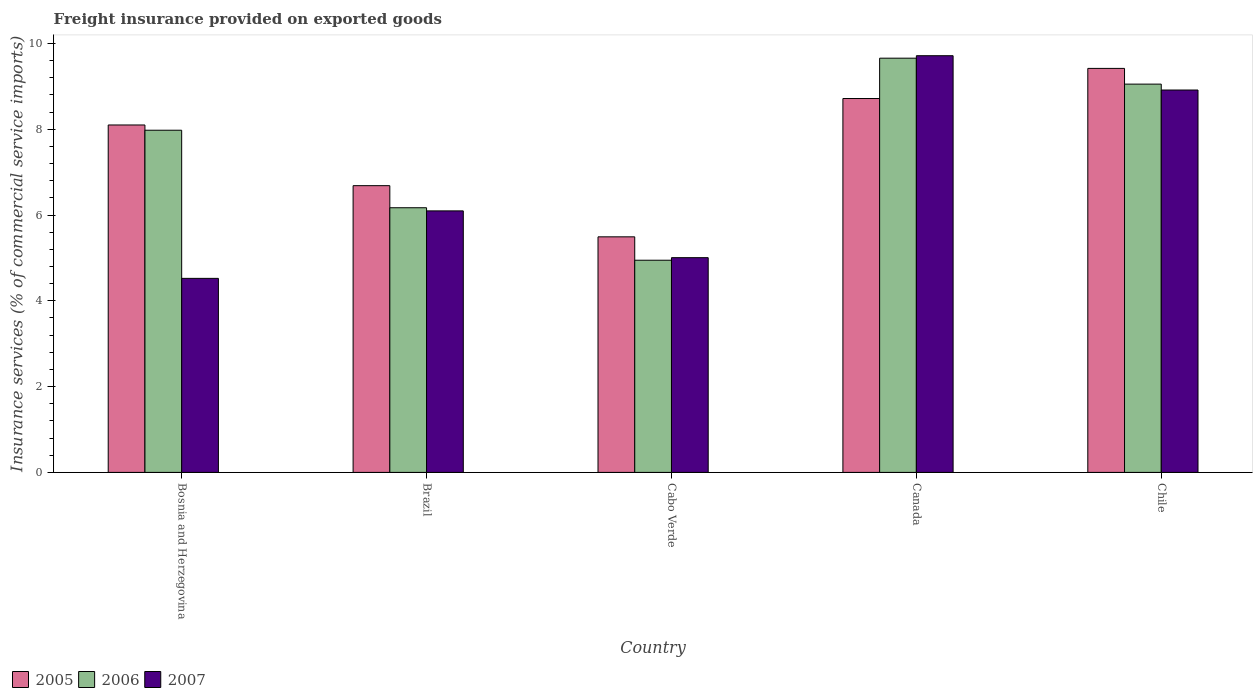How many different coloured bars are there?
Make the answer very short. 3. Are the number of bars per tick equal to the number of legend labels?
Your answer should be very brief. Yes. Are the number of bars on each tick of the X-axis equal?
Keep it short and to the point. Yes. How many bars are there on the 3rd tick from the right?
Your answer should be compact. 3. In how many cases, is the number of bars for a given country not equal to the number of legend labels?
Ensure brevity in your answer.  0. What is the freight insurance provided on exported goods in 2006 in Cabo Verde?
Your answer should be very brief. 4.95. Across all countries, what is the maximum freight insurance provided on exported goods in 2007?
Provide a short and direct response. 9.71. Across all countries, what is the minimum freight insurance provided on exported goods in 2007?
Provide a succinct answer. 4.52. In which country was the freight insurance provided on exported goods in 2006 minimum?
Your answer should be compact. Cabo Verde. What is the total freight insurance provided on exported goods in 2007 in the graph?
Ensure brevity in your answer.  34.25. What is the difference between the freight insurance provided on exported goods in 2007 in Canada and that in Chile?
Provide a short and direct response. 0.8. What is the difference between the freight insurance provided on exported goods in 2006 in Cabo Verde and the freight insurance provided on exported goods in 2005 in Bosnia and Herzegovina?
Ensure brevity in your answer.  -3.15. What is the average freight insurance provided on exported goods in 2007 per country?
Give a very brief answer. 6.85. What is the difference between the freight insurance provided on exported goods of/in 2007 and freight insurance provided on exported goods of/in 2006 in Bosnia and Herzegovina?
Your answer should be compact. -3.45. In how many countries, is the freight insurance provided on exported goods in 2007 greater than 9.2 %?
Give a very brief answer. 1. What is the ratio of the freight insurance provided on exported goods in 2005 in Brazil to that in Canada?
Give a very brief answer. 0.77. Is the difference between the freight insurance provided on exported goods in 2007 in Canada and Chile greater than the difference between the freight insurance provided on exported goods in 2006 in Canada and Chile?
Make the answer very short. Yes. What is the difference between the highest and the second highest freight insurance provided on exported goods in 2006?
Make the answer very short. 0.6. What is the difference between the highest and the lowest freight insurance provided on exported goods in 2005?
Provide a succinct answer. 3.93. In how many countries, is the freight insurance provided on exported goods in 2006 greater than the average freight insurance provided on exported goods in 2006 taken over all countries?
Your response must be concise. 3. Is the sum of the freight insurance provided on exported goods in 2006 in Bosnia and Herzegovina and Brazil greater than the maximum freight insurance provided on exported goods in 2007 across all countries?
Make the answer very short. Yes. What does the 2nd bar from the left in Canada represents?
Your answer should be very brief. 2006. Is it the case that in every country, the sum of the freight insurance provided on exported goods in 2007 and freight insurance provided on exported goods in 2006 is greater than the freight insurance provided on exported goods in 2005?
Keep it short and to the point. Yes. What is the difference between two consecutive major ticks on the Y-axis?
Make the answer very short. 2. Where does the legend appear in the graph?
Offer a very short reply. Bottom left. How are the legend labels stacked?
Your response must be concise. Horizontal. What is the title of the graph?
Provide a short and direct response. Freight insurance provided on exported goods. Does "1979" appear as one of the legend labels in the graph?
Make the answer very short. No. What is the label or title of the X-axis?
Provide a succinct answer. Country. What is the label or title of the Y-axis?
Offer a very short reply. Insurance services (% of commercial service imports). What is the Insurance services (% of commercial service imports) in 2005 in Bosnia and Herzegovina?
Ensure brevity in your answer.  8.1. What is the Insurance services (% of commercial service imports) of 2006 in Bosnia and Herzegovina?
Your response must be concise. 7.98. What is the Insurance services (% of commercial service imports) of 2007 in Bosnia and Herzegovina?
Ensure brevity in your answer.  4.52. What is the Insurance services (% of commercial service imports) in 2005 in Brazil?
Your answer should be compact. 6.68. What is the Insurance services (% of commercial service imports) in 2006 in Brazil?
Your answer should be very brief. 6.17. What is the Insurance services (% of commercial service imports) in 2007 in Brazil?
Your response must be concise. 6.1. What is the Insurance services (% of commercial service imports) in 2005 in Cabo Verde?
Ensure brevity in your answer.  5.49. What is the Insurance services (% of commercial service imports) of 2006 in Cabo Verde?
Ensure brevity in your answer.  4.95. What is the Insurance services (% of commercial service imports) in 2007 in Cabo Verde?
Make the answer very short. 5.01. What is the Insurance services (% of commercial service imports) of 2005 in Canada?
Keep it short and to the point. 8.72. What is the Insurance services (% of commercial service imports) of 2006 in Canada?
Provide a succinct answer. 9.66. What is the Insurance services (% of commercial service imports) of 2007 in Canada?
Offer a very short reply. 9.71. What is the Insurance services (% of commercial service imports) in 2005 in Chile?
Offer a terse response. 9.42. What is the Insurance services (% of commercial service imports) of 2006 in Chile?
Give a very brief answer. 9.05. What is the Insurance services (% of commercial service imports) in 2007 in Chile?
Provide a short and direct response. 8.91. Across all countries, what is the maximum Insurance services (% of commercial service imports) of 2005?
Give a very brief answer. 9.42. Across all countries, what is the maximum Insurance services (% of commercial service imports) in 2006?
Your answer should be very brief. 9.66. Across all countries, what is the maximum Insurance services (% of commercial service imports) in 2007?
Keep it short and to the point. 9.71. Across all countries, what is the minimum Insurance services (% of commercial service imports) in 2005?
Make the answer very short. 5.49. Across all countries, what is the minimum Insurance services (% of commercial service imports) of 2006?
Ensure brevity in your answer.  4.95. Across all countries, what is the minimum Insurance services (% of commercial service imports) in 2007?
Offer a very short reply. 4.52. What is the total Insurance services (% of commercial service imports) in 2005 in the graph?
Keep it short and to the point. 38.41. What is the total Insurance services (% of commercial service imports) of 2006 in the graph?
Keep it short and to the point. 37.8. What is the total Insurance services (% of commercial service imports) of 2007 in the graph?
Your answer should be compact. 34.25. What is the difference between the Insurance services (% of commercial service imports) of 2005 in Bosnia and Herzegovina and that in Brazil?
Your response must be concise. 1.41. What is the difference between the Insurance services (% of commercial service imports) in 2006 in Bosnia and Herzegovina and that in Brazil?
Ensure brevity in your answer.  1.81. What is the difference between the Insurance services (% of commercial service imports) in 2007 in Bosnia and Herzegovina and that in Brazil?
Your response must be concise. -1.57. What is the difference between the Insurance services (% of commercial service imports) in 2005 in Bosnia and Herzegovina and that in Cabo Verde?
Give a very brief answer. 2.61. What is the difference between the Insurance services (% of commercial service imports) of 2006 in Bosnia and Herzegovina and that in Cabo Verde?
Keep it short and to the point. 3.03. What is the difference between the Insurance services (% of commercial service imports) of 2007 in Bosnia and Herzegovina and that in Cabo Verde?
Your answer should be compact. -0.48. What is the difference between the Insurance services (% of commercial service imports) of 2005 in Bosnia and Herzegovina and that in Canada?
Ensure brevity in your answer.  -0.62. What is the difference between the Insurance services (% of commercial service imports) of 2006 in Bosnia and Herzegovina and that in Canada?
Your answer should be very brief. -1.68. What is the difference between the Insurance services (% of commercial service imports) in 2007 in Bosnia and Herzegovina and that in Canada?
Provide a short and direct response. -5.19. What is the difference between the Insurance services (% of commercial service imports) in 2005 in Bosnia and Herzegovina and that in Chile?
Provide a short and direct response. -1.32. What is the difference between the Insurance services (% of commercial service imports) of 2006 in Bosnia and Herzegovina and that in Chile?
Keep it short and to the point. -1.07. What is the difference between the Insurance services (% of commercial service imports) in 2007 in Bosnia and Herzegovina and that in Chile?
Your response must be concise. -4.39. What is the difference between the Insurance services (% of commercial service imports) of 2005 in Brazil and that in Cabo Verde?
Your answer should be very brief. 1.19. What is the difference between the Insurance services (% of commercial service imports) in 2006 in Brazil and that in Cabo Verde?
Your answer should be very brief. 1.22. What is the difference between the Insurance services (% of commercial service imports) in 2007 in Brazil and that in Cabo Verde?
Give a very brief answer. 1.09. What is the difference between the Insurance services (% of commercial service imports) of 2005 in Brazil and that in Canada?
Keep it short and to the point. -2.03. What is the difference between the Insurance services (% of commercial service imports) in 2006 in Brazil and that in Canada?
Provide a succinct answer. -3.49. What is the difference between the Insurance services (% of commercial service imports) of 2007 in Brazil and that in Canada?
Offer a terse response. -3.62. What is the difference between the Insurance services (% of commercial service imports) in 2005 in Brazil and that in Chile?
Ensure brevity in your answer.  -2.73. What is the difference between the Insurance services (% of commercial service imports) in 2006 in Brazil and that in Chile?
Offer a very short reply. -2.88. What is the difference between the Insurance services (% of commercial service imports) of 2007 in Brazil and that in Chile?
Provide a short and direct response. -2.82. What is the difference between the Insurance services (% of commercial service imports) of 2005 in Cabo Verde and that in Canada?
Your response must be concise. -3.22. What is the difference between the Insurance services (% of commercial service imports) in 2006 in Cabo Verde and that in Canada?
Provide a succinct answer. -4.71. What is the difference between the Insurance services (% of commercial service imports) in 2007 in Cabo Verde and that in Canada?
Provide a succinct answer. -4.71. What is the difference between the Insurance services (% of commercial service imports) of 2005 in Cabo Verde and that in Chile?
Ensure brevity in your answer.  -3.93. What is the difference between the Insurance services (% of commercial service imports) of 2006 in Cabo Verde and that in Chile?
Your answer should be very brief. -4.11. What is the difference between the Insurance services (% of commercial service imports) of 2007 in Cabo Verde and that in Chile?
Offer a very short reply. -3.91. What is the difference between the Insurance services (% of commercial service imports) of 2005 in Canada and that in Chile?
Provide a succinct answer. -0.7. What is the difference between the Insurance services (% of commercial service imports) of 2006 in Canada and that in Chile?
Give a very brief answer. 0.6. What is the difference between the Insurance services (% of commercial service imports) of 2007 in Canada and that in Chile?
Keep it short and to the point. 0.8. What is the difference between the Insurance services (% of commercial service imports) of 2005 in Bosnia and Herzegovina and the Insurance services (% of commercial service imports) of 2006 in Brazil?
Ensure brevity in your answer.  1.93. What is the difference between the Insurance services (% of commercial service imports) of 2005 in Bosnia and Herzegovina and the Insurance services (% of commercial service imports) of 2007 in Brazil?
Keep it short and to the point. 2. What is the difference between the Insurance services (% of commercial service imports) of 2006 in Bosnia and Herzegovina and the Insurance services (% of commercial service imports) of 2007 in Brazil?
Your answer should be very brief. 1.88. What is the difference between the Insurance services (% of commercial service imports) in 2005 in Bosnia and Herzegovina and the Insurance services (% of commercial service imports) in 2006 in Cabo Verde?
Offer a very short reply. 3.15. What is the difference between the Insurance services (% of commercial service imports) in 2005 in Bosnia and Herzegovina and the Insurance services (% of commercial service imports) in 2007 in Cabo Verde?
Your answer should be very brief. 3.09. What is the difference between the Insurance services (% of commercial service imports) of 2006 in Bosnia and Herzegovina and the Insurance services (% of commercial service imports) of 2007 in Cabo Verde?
Your response must be concise. 2.97. What is the difference between the Insurance services (% of commercial service imports) in 2005 in Bosnia and Herzegovina and the Insurance services (% of commercial service imports) in 2006 in Canada?
Your answer should be very brief. -1.56. What is the difference between the Insurance services (% of commercial service imports) of 2005 in Bosnia and Herzegovina and the Insurance services (% of commercial service imports) of 2007 in Canada?
Provide a succinct answer. -1.61. What is the difference between the Insurance services (% of commercial service imports) in 2006 in Bosnia and Herzegovina and the Insurance services (% of commercial service imports) in 2007 in Canada?
Provide a succinct answer. -1.74. What is the difference between the Insurance services (% of commercial service imports) in 2005 in Bosnia and Herzegovina and the Insurance services (% of commercial service imports) in 2006 in Chile?
Your response must be concise. -0.95. What is the difference between the Insurance services (% of commercial service imports) in 2005 in Bosnia and Herzegovina and the Insurance services (% of commercial service imports) in 2007 in Chile?
Your answer should be very brief. -0.81. What is the difference between the Insurance services (% of commercial service imports) in 2006 in Bosnia and Herzegovina and the Insurance services (% of commercial service imports) in 2007 in Chile?
Offer a terse response. -0.94. What is the difference between the Insurance services (% of commercial service imports) of 2005 in Brazil and the Insurance services (% of commercial service imports) of 2006 in Cabo Verde?
Offer a terse response. 1.74. What is the difference between the Insurance services (% of commercial service imports) in 2005 in Brazil and the Insurance services (% of commercial service imports) in 2007 in Cabo Verde?
Your answer should be compact. 1.68. What is the difference between the Insurance services (% of commercial service imports) of 2006 in Brazil and the Insurance services (% of commercial service imports) of 2007 in Cabo Verde?
Your response must be concise. 1.16. What is the difference between the Insurance services (% of commercial service imports) of 2005 in Brazil and the Insurance services (% of commercial service imports) of 2006 in Canada?
Your response must be concise. -2.97. What is the difference between the Insurance services (% of commercial service imports) of 2005 in Brazil and the Insurance services (% of commercial service imports) of 2007 in Canada?
Your response must be concise. -3.03. What is the difference between the Insurance services (% of commercial service imports) in 2006 in Brazil and the Insurance services (% of commercial service imports) in 2007 in Canada?
Provide a short and direct response. -3.54. What is the difference between the Insurance services (% of commercial service imports) in 2005 in Brazil and the Insurance services (% of commercial service imports) in 2006 in Chile?
Offer a very short reply. -2.37. What is the difference between the Insurance services (% of commercial service imports) in 2005 in Brazil and the Insurance services (% of commercial service imports) in 2007 in Chile?
Your response must be concise. -2.23. What is the difference between the Insurance services (% of commercial service imports) of 2006 in Brazil and the Insurance services (% of commercial service imports) of 2007 in Chile?
Ensure brevity in your answer.  -2.74. What is the difference between the Insurance services (% of commercial service imports) in 2005 in Cabo Verde and the Insurance services (% of commercial service imports) in 2006 in Canada?
Provide a short and direct response. -4.16. What is the difference between the Insurance services (% of commercial service imports) of 2005 in Cabo Verde and the Insurance services (% of commercial service imports) of 2007 in Canada?
Ensure brevity in your answer.  -4.22. What is the difference between the Insurance services (% of commercial service imports) of 2006 in Cabo Verde and the Insurance services (% of commercial service imports) of 2007 in Canada?
Offer a terse response. -4.77. What is the difference between the Insurance services (% of commercial service imports) in 2005 in Cabo Verde and the Insurance services (% of commercial service imports) in 2006 in Chile?
Your response must be concise. -3.56. What is the difference between the Insurance services (% of commercial service imports) in 2005 in Cabo Verde and the Insurance services (% of commercial service imports) in 2007 in Chile?
Provide a succinct answer. -3.42. What is the difference between the Insurance services (% of commercial service imports) in 2006 in Cabo Verde and the Insurance services (% of commercial service imports) in 2007 in Chile?
Offer a very short reply. -3.97. What is the difference between the Insurance services (% of commercial service imports) in 2005 in Canada and the Insurance services (% of commercial service imports) in 2006 in Chile?
Keep it short and to the point. -0.34. What is the difference between the Insurance services (% of commercial service imports) of 2005 in Canada and the Insurance services (% of commercial service imports) of 2007 in Chile?
Your answer should be compact. -0.2. What is the difference between the Insurance services (% of commercial service imports) of 2006 in Canada and the Insurance services (% of commercial service imports) of 2007 in Chile?
Your response must be concise. 0.74. What is the average Insurance services (% of commercial service imports) of 2005 per country?
Your response must be concise. 7.68. What is the average Insurance services (% of commercial service imports) of 2006 per country?
Your answer should be very brief. 7.56. What is the average Insurance services (% of commercial service imports) in 2007 per country?
Make the answer very short. 6.85. What is the difference between the Insurance services (% of commercial service imports) of 2005 and Insurance services (% of commercial service imports) of 2006 in Bosnia and Herzegovina?
Offer a very short reply. 0.12. What is the difference between the Insurance services (% of commercial service imports) of 2005 and Insurance services (% of commercial service imports) of 2007 in Bosnia and Herzegovina?
Your answer should be compact. 3.58. What is the difference between the Insurance services (% of commercial service imports) in 2006 and Insurance services (% of commercial service imports) in 2007 in Bosnia and Herzegovina?
Provide a succinct answer. 3.45. What is the difference between the Insurance services (% of commercial service imports) of 2005 and Insurance services (% of commercial service imports) of 2006 in Brazil?
Make the answer very short. 0.51. What is the difference between the Insurance services (% of commercial service imports) in 2005 and Insurance services (% of commercial service imports) in 2007 in Brazil?
Provide a succinct answer. 0.59. What is the difference between the Insurance services (% of commercial service imports) of 2006 and Insurance services (% of commercial service imports) of 2007 in Brazil?
Your answer should be very brief. 0.07. What is the difference between the Insurance services (% of commercial service imports) in 2005 and Insurance services (% of commercial service imports) in 2006 in Cabo Verde?
Ensure brevity in your answer.  0.55. What is the difference between the Insurance services (% of commercial service imports) in 2005 and Insurance services (% of commercial service imports) in 2007 in Cabo Verde?
Provide a succinct answer. 0.49. What is the difference between the Insurance services (% of commercial service imports) of 2006 and Insurance services (% of commercial service imports) of 2007 in Cabo Verde?
Your response must be concise. -0.06. What is the difference between the Insurance services (% of commercial service imports) in 2005 and Insurance services (% of commercial service imports) in 2006 in Canada?
Offer a very short reply. -0.94. What is the difference between the Insurance services (% of commercial service imports) in 2005 and Insurance services (% of commercial service imports) in 2007 in Canada?
Provide a succinct answer. -1. What is the difference between the Insurance services (% of commercial service imports) in 2006 and Insurance services (% of commercial service imports) in 2007 in Canada?
Give a very brief answer. -0.06. What is the difference between the Insurance services (% of commercial service imports) in 2005 and Insurance services (% of commercial service imports) in 2006 in Chile?
Provide a succinct answer. 0.37. What is the difference between the Insurance services (% of commercial service imports) of 2005 and Insurance services (% of commercial service imports) of 2007 in Chile?
Your answer should be very brief. 0.5. What is the difference between the Insurance services (% of commercial service imports) in 2006 and Insurance services (% of commercial service imports) in 2007 in Chile?
Ensure brevity in your answer.  0.14. What is the ratio of the Insurance services (% of commercial service imports) of 2005 in Bosnia and Herzegovina to that in Brazil?
Your response must be concise. 1.21. What is the ratio of the Insurance services (% of commercial service imports) of 2006 in Bosnia and Herzegovina to that in Brazil?
Make the answer very short. 1.29. What is the ratio of the Insurance services (% of commercial service imports) in 2007 in Bosnia and Herzegovina to that in Brazil?
Offer a terse response. 0.74. What is the ratio of the Insurance services (% of commercial service imports) of 2005 in Bosnia and Herzegovina to that in Cabo Verde?
Ensure brevity in your answer.  1.47. What is the ratio of the Insurance services (% of commercial service imports) of 2006 in Bosnia and Herzegovina to that in Cabo Verde?
Offer a very short reply. 1.61. What is the ratio of the Insurance services (% of commercial service imports) of 2007 in Bosnia and Herzegovina to that in Cabo Verde?
Your answer should be compact. 0.9. What is the ratio of the Insurance services (% of commercial service imports) in 2005 in Bosnia and Herzegovina to that in Canada?
Give a very brief answer. 0.93. What is the ratio of the Insurance services (% of commercial service imports) of 2006 in Bosnia and Herzegovina to that in Canada?
Offer a very short reply. 0.83. What is the ratio of the Insurance services (% of commercial service imports) of 2007 in Bosnia and Herzegovina to that in Canada?
Your response must be concise. 0.47. What is the ratio of the Insurance services (% of commercial service imports) of 2005 in Bosnia and Herzegovina to that in Chile?
Provide a succinct answer. 0.86. What is the ratio of the Insurance services (% of commercial service imports) of 2006 in Bosnia and Herzegovina to that in Chile?
Offer a very short reply. 0.88. What is the ratio of the Insurance services (% of commercial service imports) of 2007 in Bosnia and Herzegovina to that in Chile?
Provide a succinct answer. 0.51. What is the ratio of the Insurance services (% of commercial service imports) of 2005 in Brazil to that in Cabo Verde?
Your answer should be very brief. 1.22. What is the ratio of the Insurance services (% of commercial service imports) in 2006 in Brazil to that in Cabo Verde?
Your answer should be compact. 1.25. What is the ratio of the Insurance services (% of commercial service imports) in 2007 in Brazil to that in Cabo Verde?
Ensure brevity in your answer.  1.22. What is the ratio of the Insurance services (% of commercial service imports) of 2005 in Brazil to that in Canada?
Give a very brief answer. 0.77. What is the ratio of the Insurance services (% of commercial service imports) of 2006 in Brazil to that in Canada?
Your answer should be compact. 0.64. What is the ratio of the Insurance services (% of commercial service imports) of 2007 in Brazil to that in Canada?
Offer a very short reply. 0.63. What is the ratio of the Insurance services (% of commercial service imports) in 2005 in Brazil to that in Chile?
Your answer should be compact. 0.71. What is the ratio of the Insurance services (% of commercial service imports) of 2006 in Brazil to that in Chile?
Ensure brevity in your answer.  0.68. What is the ratio of the Insurance services (% of commercial service imports) in 2007 in Brazil to that in Chile?
Provide a short and direct response. 0.68. What is the ratio of the Insurance services (% of commercial service imports) of 2005 in Cabo Verde to that in Canada?
Offer a very short reply. 0.63. What is the ratio of the Insurance services (% of commercial service imports) of 2006 in Cabo Verde to that in Canada?
Provide a succinct answer. 0.51. What is the ratio of the Insurance services (% of commercial service imports) in 2007 in Cabo Verde to that in Canada?
Provide a succinct answer. 0.52. What is the ratio of the Insurance services (% of commercial service imports) of 2005 in Cabo Verde to that in Chile?
Provide a succinct answer. 0.58. What is the ratio of the Insurance services (% of commercial service imports) in 2006 in Cabo Verde to that in Chile?
Your answer should be very brief. 0.55. What is the ratio of the Insurance services (% of commercial service imports) of 2007 in Cabo Verde to that in Chile?
Keep it short and to the point. 0.56. What is the ratio of the Insurance services (% of commercial service imports) in 2005 in Canada to that in Chile?
Make the answer very short. 0.93. What is the ratio of the Insurance services (% of commercial service imports) of 2006 in Canada to that in Chile?
Offer a terse response. 1.07. What is the ratio of the Insurance services (% of commercial service imports) of 2007 in Canada to that in Chile?
Your answer should be compact. 1.09. What is the difference between the highest and the second highest Insurance services (% of commercial service imports) of 2005?
Ensure brevity in your answer.  0.7. What is the difference between the highest and the second highest Insurance services (% of commercial service imports) in 2006?
Provide a short and direct response. 0.6. What is the difference between the highest and the second highest Insurance services (% of commercial service imports) in 2007?
Your response must be concise. 0.8. What is the difference between the highest and the lowest Insurance services (% of commercial service imports) of 2005?
Provide a short and direct response. 3.93. What is the difference between the highest and the lowest Insurance services (% of commercial service imports) in 2006?
Your answer should be compact. 4.71. What is the difference between the highest and the lowest Insurance services (% of commercial service imports) in 2007?
Ensure brevity in your answer.  5.19. 